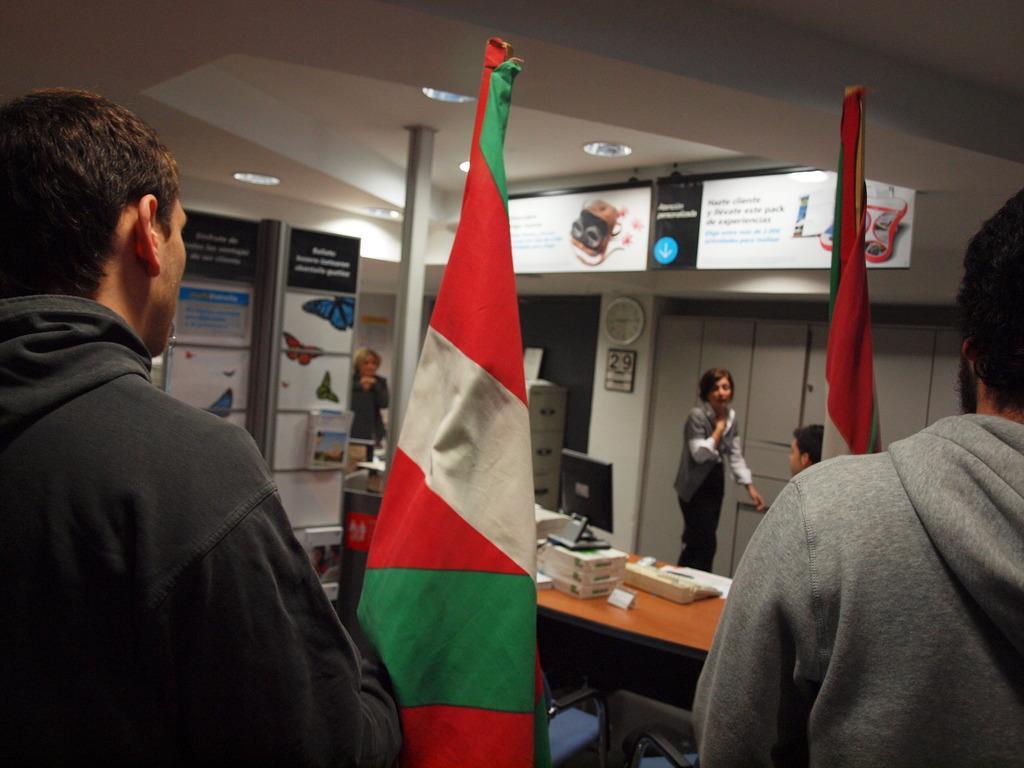In one or two sentences, can you explain what this image depicts? In this image I see 5 persons and 2 flags, few boards and pictures on it and I can also see a table and few things on it and I can also see a clock on the wall. 